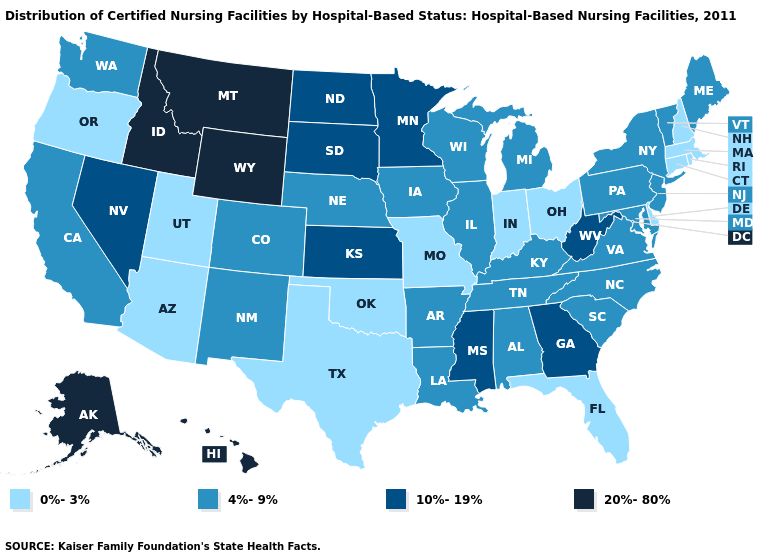Does Oklahoma have the same value as Louisiana?
Write a very short answer. No. Name the states that have a value in the range 4%-9%?
Quick response, please. Alabama, Arkansas, California, Colorado, Illinois, Iowa, Kentucky, Louisiana, Maine, Maryland, Michigan, Nebraska, New Jersey, New Mexico, New York, North Carolina, Pennsylvania, South Carolina, Tennessee, Vermont, Virginia, Washington, Wisconsin. Which states have the lowest value in the Northeast?
Write a very short answer. Connecticut, Massachusetts, New Hampshire, Rhode Island. What is the value of Minnesota?
Answer briefly. 10%-19%. Name the states that have a value in the range 4%-9%?
Give a very brief answer. Alabama, Arkansas, California, Colorado, Illinois, Iowa, Kentucky, Louisiana, Maine, Maryland, Michigan, Nebraska, New Jersey, New Mexico, New York, North Carolina, Pennsylvania, South Carolina, Tennessee, Vermont, Virginia, Washington, Wisconsin. Does Oregon have the lowest value in the West?
Be succinct. Yes. What is the highest value in the USA?
Short answer required. 20%-80%. What is the value of Connecticut?
Concise answer only. 0%-3%. Does Idaho have a higher value than Florida?
Quick response, please. Yes. Does Pennsylvania have a higher value than Massachusetts?
Quick response, please. Yes. Does Georgia have the highest value in the South?
Short answer required. Yes. Does South Dakota have the lowest value in the USA?
Keep it brief. No. Name the states that have a value in the range 4%-9%?
Short answer required. Alabama, Arkansas, California, Colorado, Illinois, Iowa, Kentucky, Louisiana, Maine, Maryland, Michigan, Nebraska, New Jersey, New Mexico, New York, North Carolina, Pennsylvania, South Carolina, Tennessee, Vermont, Virginia, Washington, Wisconsin. How many symbols are there in the legend?
Write a very short answer. 4. Among the states that border Wyoming , does Utah have the lowest value?
Keep it brief. Yes. 